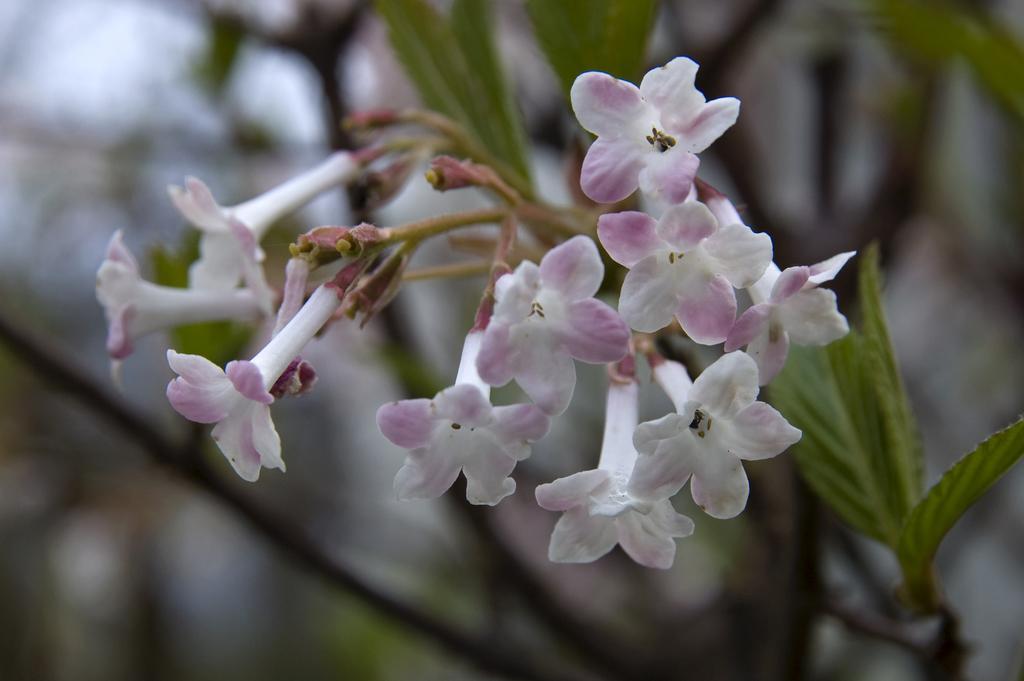In one or two sentences, can you explain what this image depicts? In this image we can see a bunch of flowers to the stem of a plant. 